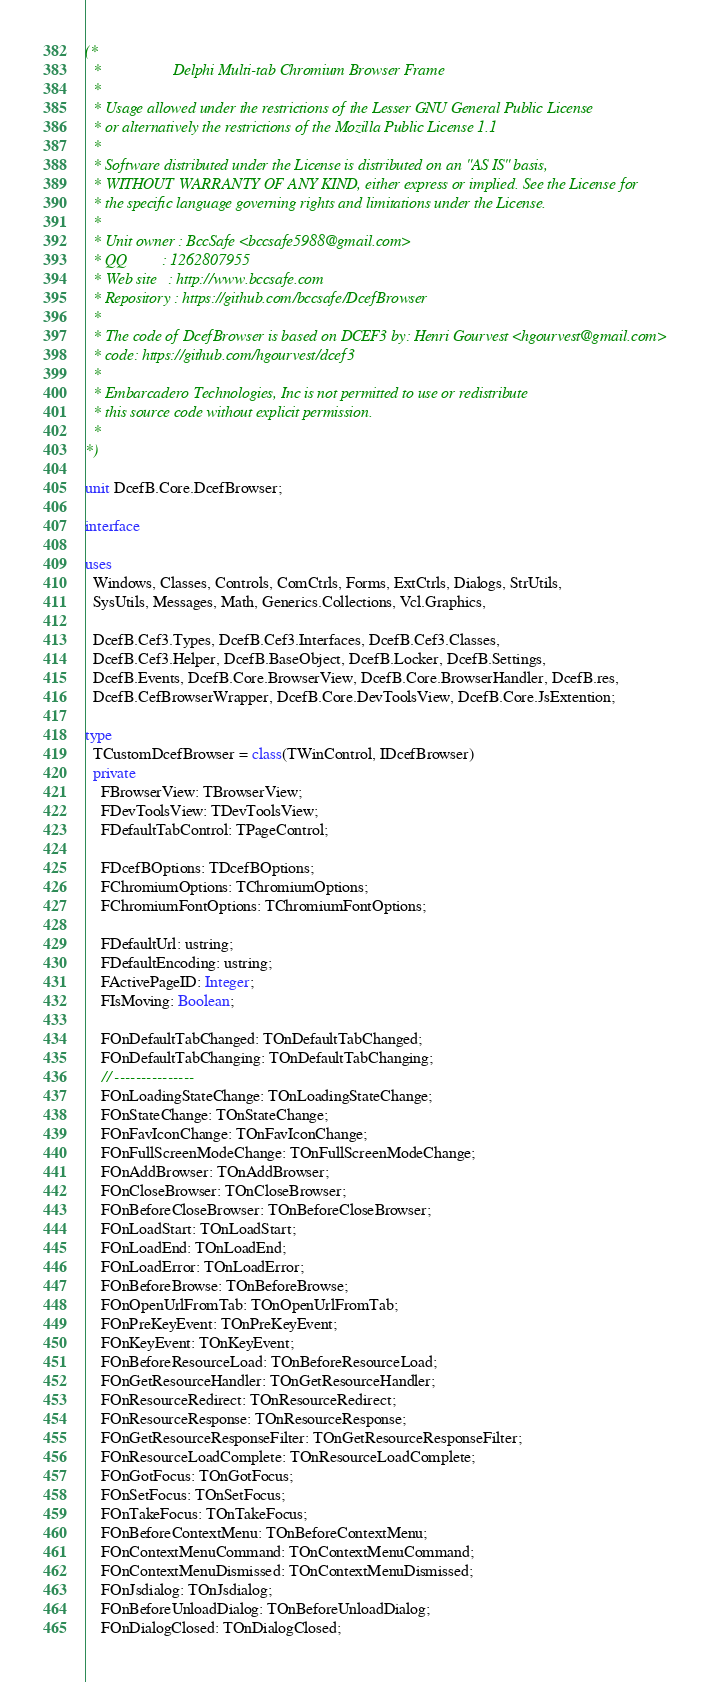<code> <loc_0><loc_0><loc_500><loc_500><_Pascal_>(*  *                  Delphi Multi-tab Chromium Browser Frame
  *
  * Usage allowed under the restrictions of the Lesser GNU General Public License
  * or alternatively the restrictions of the Mozilla Public License 1.1
  *
  * Software distributed under the License is distributed on an "AS IS" basis,
  * WITHOUT WARRANTY OF ANY KIND, either express or implied. See the License for
  * the specific language governing rights and limitations under the License.
  *
  * Unit owner : BccSafe <bccsafe5988@gmail.com>
  * QQ         : 1262807955
  * Web site   : http://www.bccsafe.com
  * Repository : https://github.com/bccsafe/DcefBrowser
  *
  * The code of DcefBrowser is based on DCEF3 by: Henri Gourvest <hgourvest@gmail.com>
  * code: https://github.com/hgourvest/dcef3
  *
  * Embarcadero Technologies, Inc is not permitted to use or redistribute
  * this source code without explicit permission.
  *
*)

unit DcefB.Core.DcefBrowser;

interface

uses
  Windows, Classes, Controls, ComCtrls, Forms, ExtCtrls, Dialogs, StrUtils,
  SysUtils, Messages, Math, Generics.Collections, Vcl.Graphics,

  DcefB.Cef3.Types, DcefB.Cef3.Interfaces, DcefB.Cef3.Classes,
  DcefB.Cef3.Helper, DcefB.BaseObject, DcefB.Locker, DcefB.Settings,
  DcefB.Events, DcefB.Core.BrowserView, DcefB.Core.BrowserHandler, DcefB.res,
  DcefB.CefBrowserWrapper, DcefB.Core.DevToolsView, DcefB.Core.JsExtention;

type
  TCustomDcefBrowser = class(TWinControl, IDcefBrowser)
  private
    FBrowserView: TBrowserView;
    FDevToolsView: TDevToolsView;
    FDefaultTabControl: TPageControl;

    FDcefBOptions: TDcefBOptions;
    FChromiumOptions: TChromiumOptions;
    FChromiumFontOptions: TChromiumFontOptions;

    FDefaultUrl: ustring;
    FDefaultEncoding: ustring;
    FActivePageID: Integer;
    FIsMoving: Boolean;

    FOnDefaultTabChanged: TOnDefaultTabChanged;
    FOnDefaultTabChanging: TOnDefaultTabChanging;
    // ---------------
    FOnLoadingStateChange: TOnLoadingStateChange;
    FOnStateChange: TOnStateChange;
    FOnFavIconChange: TOnFavIconChange;
    FOnFullScreenModeChange: TOnFullScreenModeChange;
    FOnAddBrowser: TOnAddBrowser;
    FOnCloseBrowser: TOnCloseBrowser;
    FOnBeforeCloseBrowser: TOnBeforeCloseBrowser;
    FOnLoadStart: TOnLoadStart;
    FOnLoadEnd: TOnLoadEnd;
    FOnLoadError: TOnLoadError;
    FOnBeforeBrowse: TOnBeforeBrowse;
    FOnOpenUrlFromTab: TOnOpenUrlFromTab;
    FOnPreKeyEvent: TOnPreKeyEvent;
    FOnKeyEvent: TOnKeyEvent;
    FOnBeforeResourceLoad: TOnBeforeResourceLoad;
    FOnGetResourceHandler: TOnGetResourceHandler;
    FOnResourceRedirect: TOnResourceRedirect;
    FOnResourceResponse: TOnResourceResponse;
    FOnGetResourceResponseFilter: TOnGetResourceResponseFilter;
    FOnResourceLoadComplete: TOnResourceLoadComplete;
    FOnGotFocus: TOnGotFocus;
    FOnSetFocus: TOnSetFocus;
    FOnTakeFocus: TOnTakeFocus;
    FOnBeforeContextMenu: TOnBeforeContextMenu;
    FOnContextMenuCommand: TOnContextMenuCommand;
    FOnContextMenuDismissed: TOnContextMenuDismissed;
    FOnJsdialog: TOnJsdialog;
    FOnBeforeUnloadDialog: TOnBeforeUnloadDialog;
    FOnDialogClosed: TOnDialogClosed;</code> 